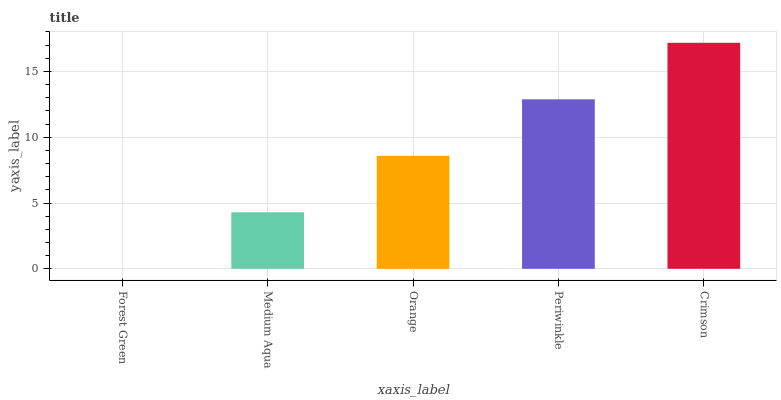Is Forest Green the minimum?
Answer yes or no. Yes. Is Crimson the maximum?
Answer yes or no. Yes. Is Medium Aqua the minimum?
Answer yes or no. No. Is Medium Aqua the maximum?
Answer yes or no. No. Is Medium Aqua greater than Forest Green?
Answer yes or no. Yes. Is Forest Green less than Medium Aqua?
Answer yes or no. Yes. Is Forest Green greater than Medium Aqua?
Answer yes or no. No. Is Medium Aqua less than Forest Green?
Answer yes or no. No. Is Orange the high median?
Answer yes or no. Yes. Is Orange the low median?
Answer yes or no. Yes. Is Medium Aqua the high median?
Answer yes or no. No. Is Forest Green the low median?
Answer yes or no. No. 